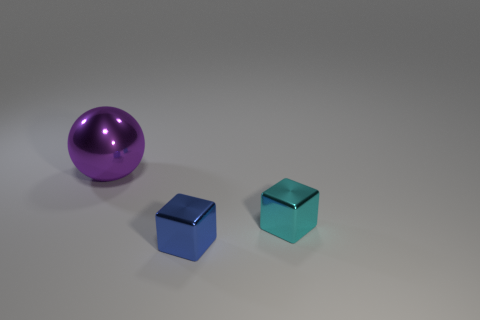Add 1 purple metallic cylinders. How many objects exist? 4 Subtract all cubes. How many objects are left? 1 Add 1 big balls. How many big balls are left? 2 Add 3 tiny yellow metallic spheres. How many tiny yellow metallic spheres exist? 3 Subtract 0 brown blocks. How many objects are left? 3 Subtract all large rubber objects. Subtract all small objects. How many objects are left? 1 